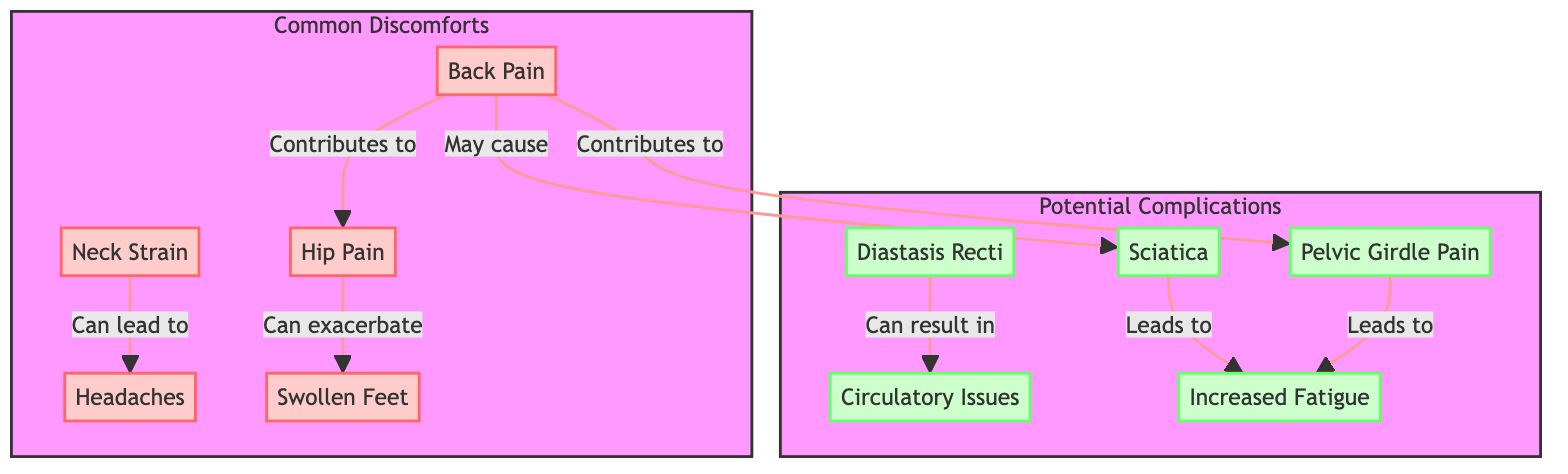What are the common discomforts listed in the diagram? The diagram shows five common discomforts: Back Pain, Neck Strain, Headaches, Hip Pain, and Swollen Feet. They are all mentioned within the subgraph labeled "Common Discomforts."
Answer: Back Pain, Neck Strain, Headaches, Hip Pain, Swollen Feet How many potential complications are illustrated in the diagram? The diagram includes five potential complications listed under the subgraph labeled "Potential Complications": Sciatica, Diastasis Recti, Pelvic Girdle Pain, Circulatory Issues, and Increased Fatigue. Counting these, we find there are five complications.
Answer: 5 Which complication is associated with Diastasis Recti? The diagram shows a single directed relationship from Diastasis Recti, which leads to Circulatory Issues, establishing that Diastasis Recti can result in that complication.
Answer: Circulatory Issues What does Back Pain contribute to according to the diagram? The diagram indicates two connections from Back Pain: it contributes to Hip Pain, and it may cause Sciatica. Thus, Back Pain is shown to contribute to at least two discomforts/complications.
Answer: Hip Pain, Sciatica Which discomfort can exacerbate Swollen Feet? The diagram illustrates a directed relationship from Hip Pain to Swollen Feet, showing that Hip Pain can exacerbate Swollen Feet.
Answer: Hip Pain How does Sciatica affect fatigue? According to the diagram, Sciatica leads to Increased Fatigue. To arrive at this conclusion, we see that Sciatica has a direct connection implying that it contributes to feelings of fatigue.
Answer: Increased Fatigue What are the relationships between Neck Strain and Headaches? The relationship between Neck Strain and Headaches is shown as a directional connection; Neck Strain can lead to headaches. This means that when someone experiences neck strain, it may result in headaches.
Answer: Can lead to How are common discomforts visually differentiated from potential complications in the diagram? The common discomforts are enclosed in a subgraph with a different color fill and outline (red), while potential complications are shown in a separate subgraph with a distinct color (green). This visual distinction helps viewers quickly differentiate the two categories.
Answer: Different colors (red for discomforts, green for complications) What leads to Increased Fatigue apart from Sciatica? The diagram shows two separate sources that lead to Increased Fatigue: Sciatica and Pelvic Girdle Pain. Both have direct connections that indicate they are causes for increased fatigue during pregnancy.
Answer: Sciatica, Pelvic Girdle Pain 